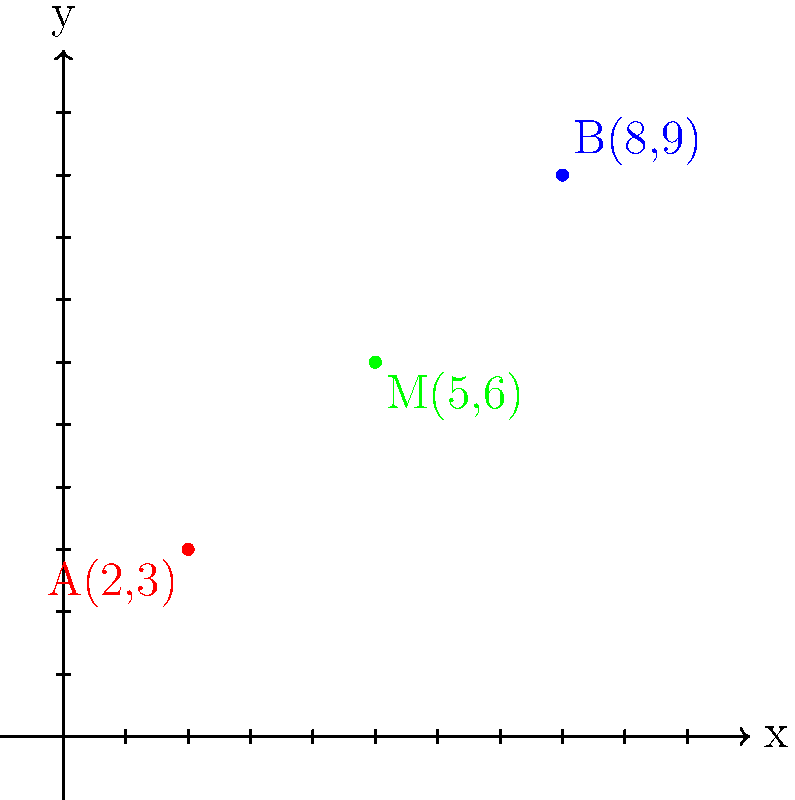As the center's leader, you're organizing a team-building exercise. Two team members, represented by points A(2,3) and B(8,9) on a coordinate plane, need to meet at the midpoint between their positions. What are the coordinates of the midpoint M where they should meet? To find the midpoint M between two points A(x₁, y₁) and B(x₂, y₂), we use the midpoint formula:

$$ M = (\frac{x_1 + x_2}{2}, \frac{y_1 + y_2}{2}) $$

Given:
- Point A: (2, 3)
- Point B: (8, 9)

Step 1: Calculate the x-coordinate of the midpoint:
$$ x_M = \frac{x_1 + x_2}{2} = \frac{2 + 8}{2} = \frac{10}{2} = 5 $$

Step 2: Calculate the y-coordinate of the midpoint:
$$ y_M = \frac{y_1 + y_2}{2} = \frac{3 + 9}{2} = \frac{12}{2} = 6 $$

Step 3: Combine the results to get the midpoint coordinates:
$$ M = (5, 6) $$

Therefore, the midpoint M where the team members should meet is at coordinates (5, 6).
Answer: (5, 6) 